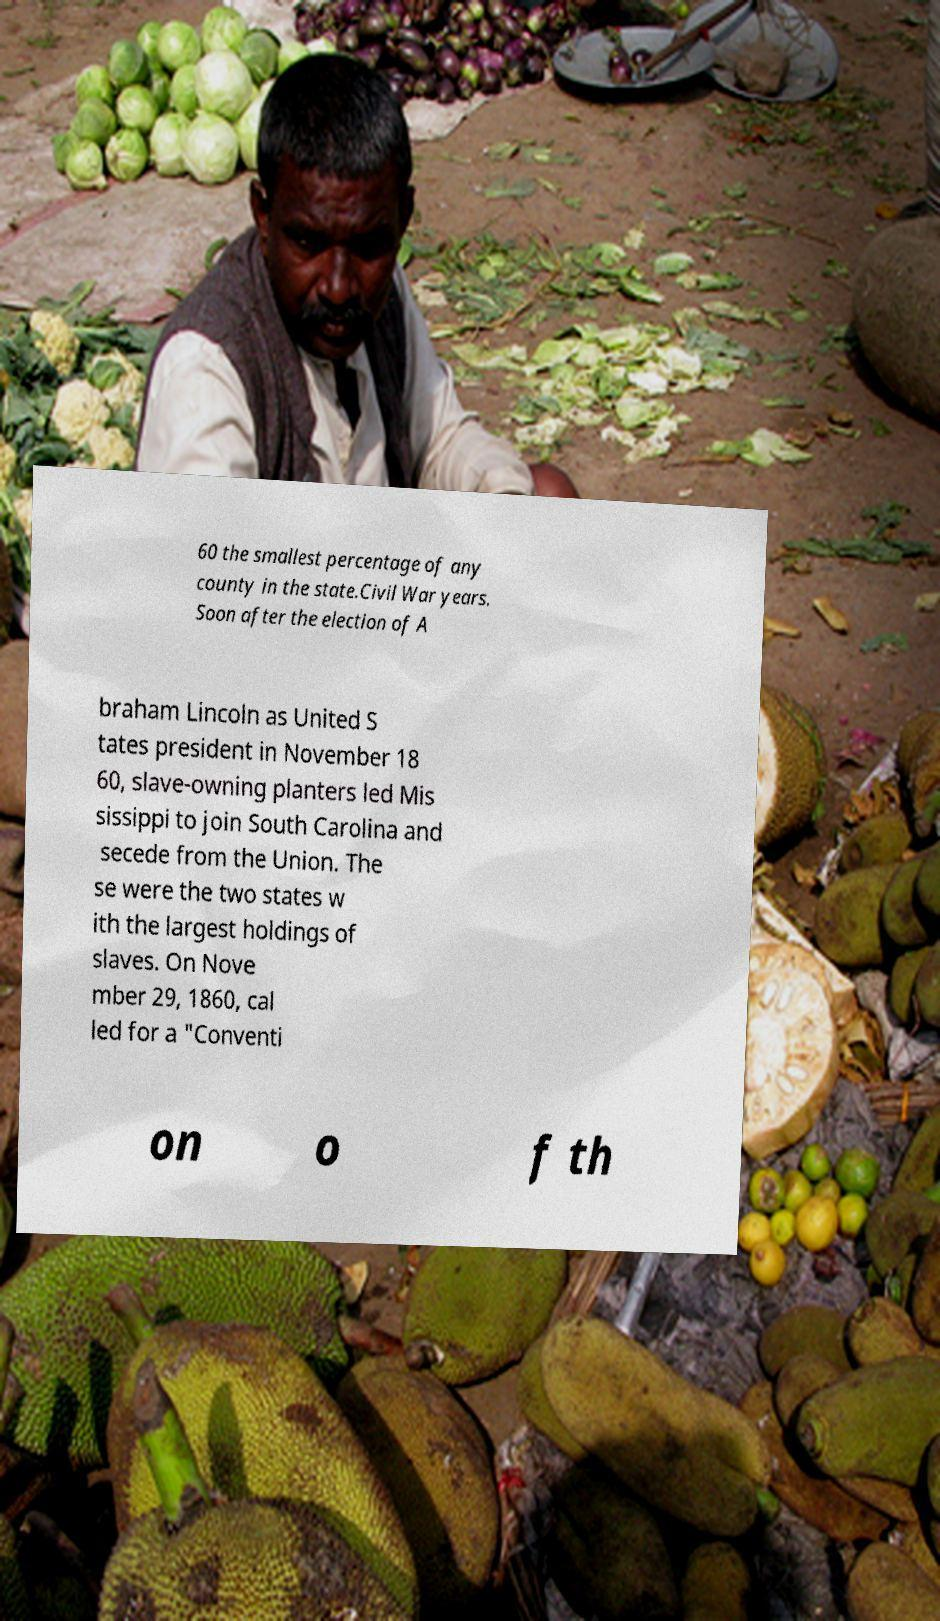I need the written content from this picture converted into text. Can you do that? 60 the smallest percentage of any county in the state.Civil War years. Soon after the election of A braham Lincoln as United S tates president in November 18 60, slave-owning planters led Mis sissippi to join South Carolina and secede from the Union. The se were the two states w ith the largest holdings of slaves. On Nove mber 29, 1860, cal led for a "Conventi on o f th 